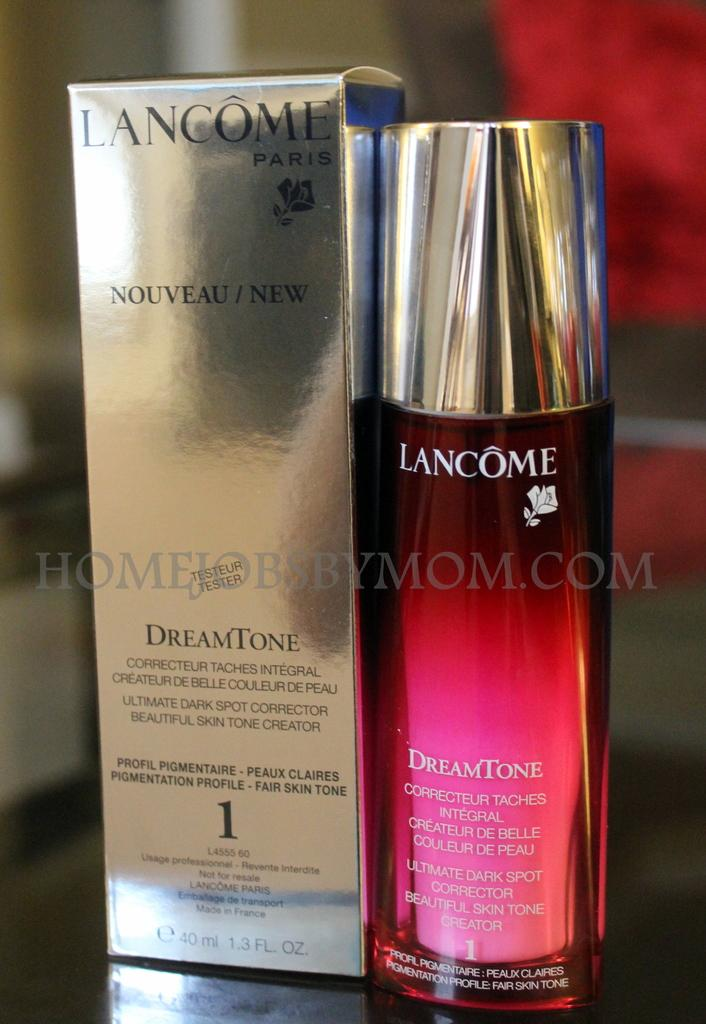<image>
Give a short and clear explanation of the subsequent image. A display of an item called Lancome Dream Tone. 